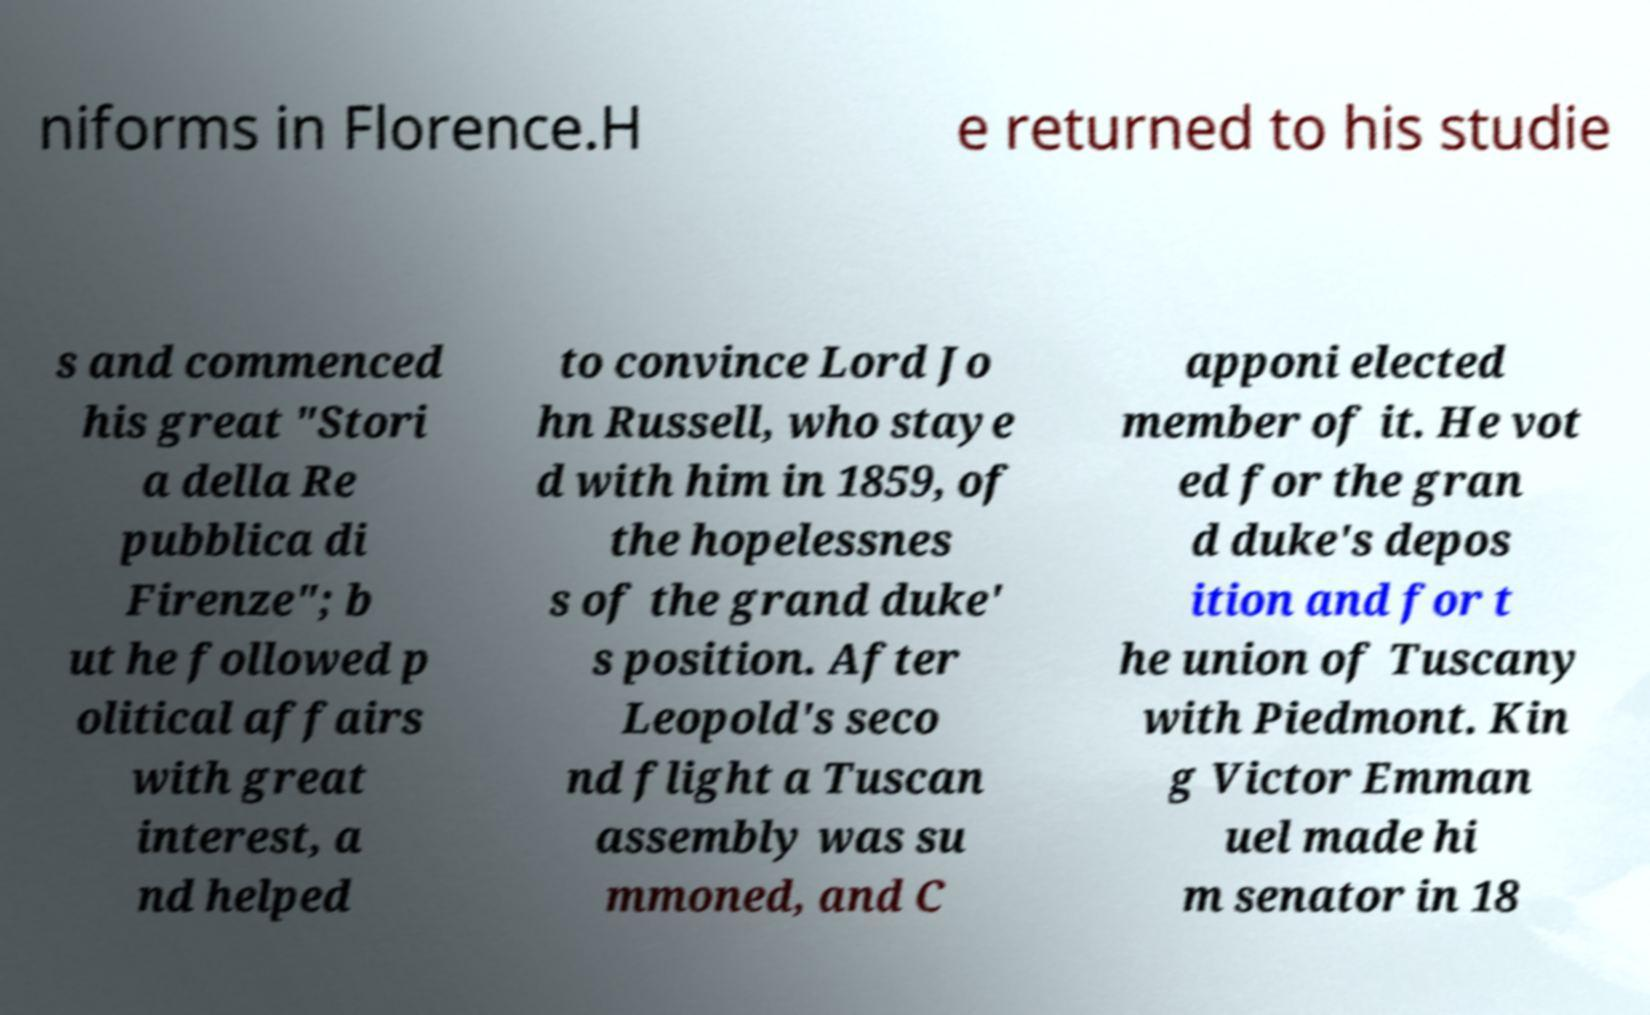There's text embedded in this image that I need extracted. Can you transcribe it verbatim? niforms in Florence.H e returned to his studie s and commenced his great "Stori a della Re pubblica di Firenze"; b ut he followed p olitical affairs with great interest, a nd helped to convince Lord Jo hn Russell, who staye d with him in 1859, of the hopelessnes s of the grand duke' s position. After Leopold's seco nd flight a Tuscan assembly was su mmoned, and C apponi elected member of it. He vot ed for the gran d duke's depos ition and for t he union of Tuscany with Piedmont. Kin g Victor Emman uel made hi m senator in 18 